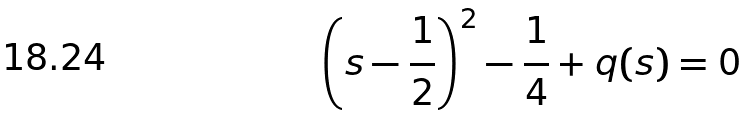Convert formula to latex. <formula><loc_0><loc_0><loc_500><loc_500>\left ( s - \frac { 1 } { 2 } \right ) ^ { 2 } - \frac { 1 } { 4 } + q ( s ) = 0</formula> 